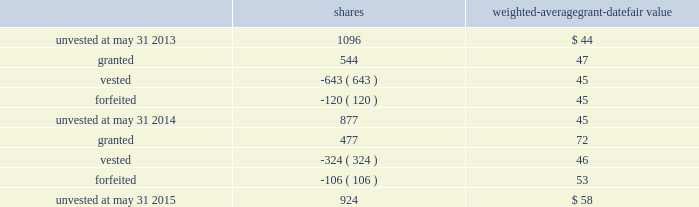The performance units granted to certain executives in fiscal 2014 were based on a one-year performance period .
After the compensation committee certified the performance results , 25% ( 25 % ) of the performance units converted to unrestricted shares .
The remaining 75% ( 75 % ) converted to restricted shares that vest in equal installments on each of the first three anniversaries of the conversion date .
The performance units granted to certain executives during fiscal 2015 were based on a three-year performance period .
After the compensation committee certifies the performance results for the three-year period , performance units earned will convert into unrestricted common stock .
The compensation committee may set a range of possible performance-based outcomes for performance units .
Depending on the achievement of the performance measures , the grantee may earn up to 200% ( 200 % ) of the target number of shares .
For awards with only performance conditions , we recognize compensation expense over the performance period using the grant date fair value of the award , which is based on the number of shares expected to be earned according to the level of achievement of performance goals .
If the number of shares expected to be earned were to change at any time during the performance period , we would make a cumulative adjustment to share-based compensation expense based on the revised number of shares expected to be earned .
During fiscal 2015 , certain executives were granted performance units that we refer to as leveraged performance units , or lpus .
Lpus contain a market condition based on our relative stock price growth over a three-year performance period .
The lpus contain a minimum threshold performance which , if not met , would result in no payout .
The lpus also contain a maximum award opportunity set as a fixed dollar and fixed number of shares .
After the three-year performance period , one-third of any earned units converts to unrestricted common stock .
The remaining two-thirds convert to restricted stock that will vest in equal installments on each of the first two anniversaries of the conversion date .
We recognize share-based compensation expense based on the grant date fair value of the lpus , as determined by use of a monte carlo model , on a straight-line basis over the requisite service period for each separately vesting portion of the lpu award .
Total shareholder return units before fiscal 2015 , certain of our executives were granted total shareholder return ( 201ctsr 201d ) units , which are performance-based restricted stock units that are earned based on our total shareholder return over a three-year performance period compared to companies in the s&p 500 .
Once the performance results are certified , tsr units convert into unrestricted common stock .
Depending on our performance , the grantee may earn up to 200% ( 200 % ) of the target number of shares .
The target number of tsr units for each executive is set by the compensation committee .
We recognize share-based compensation expense based on the grant date fair value of the tsr units , as determined by use of a monte carlo model , on a straight-line basis over the vesting period .
The table summarizes the changes in unvested share-based awards for the years ended may 31 , 2015 and 2014 ( shares in thousands ) : shares weighted-average grant-date fair value .
Global payments inc .
| 2015 form 10-k annual report 2013 81 .
What is the total amount of unvested shares gifted by the company during the three year period? 
Rationale: to find out the total amount of unvested shares the company one must added up the shares given by the company over the course of the three years .
Computations: ((1096 + 877) + 924)
Answer: 2897.0. 